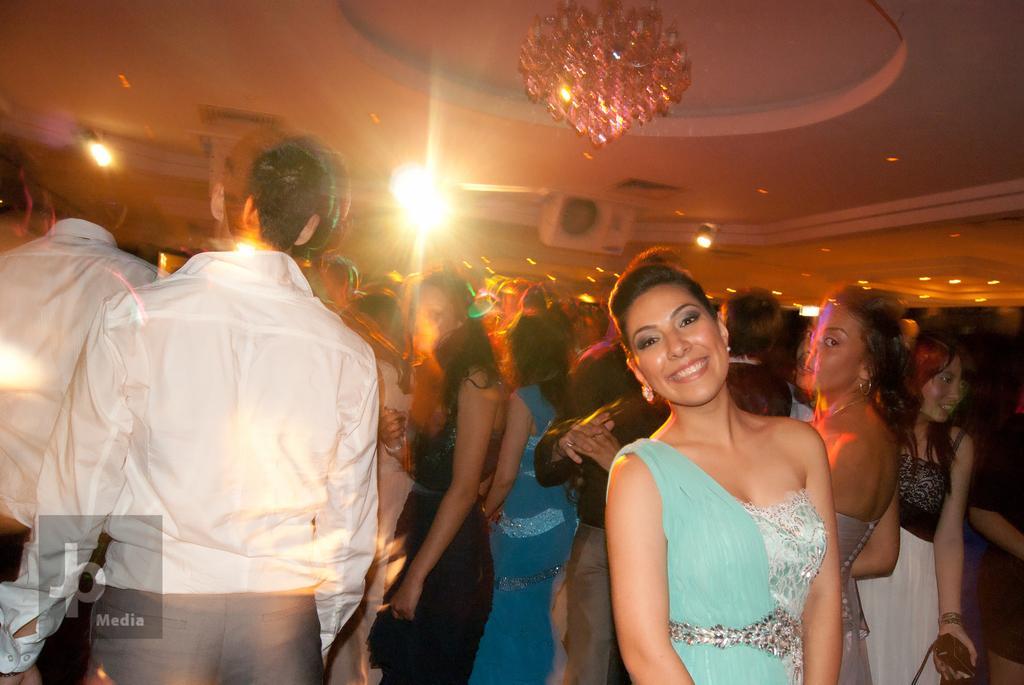Please provide a concise description of this image. In this picture we can see many people standing. There is a chandelier, a few lights and a device on top. A watermark is visible. 